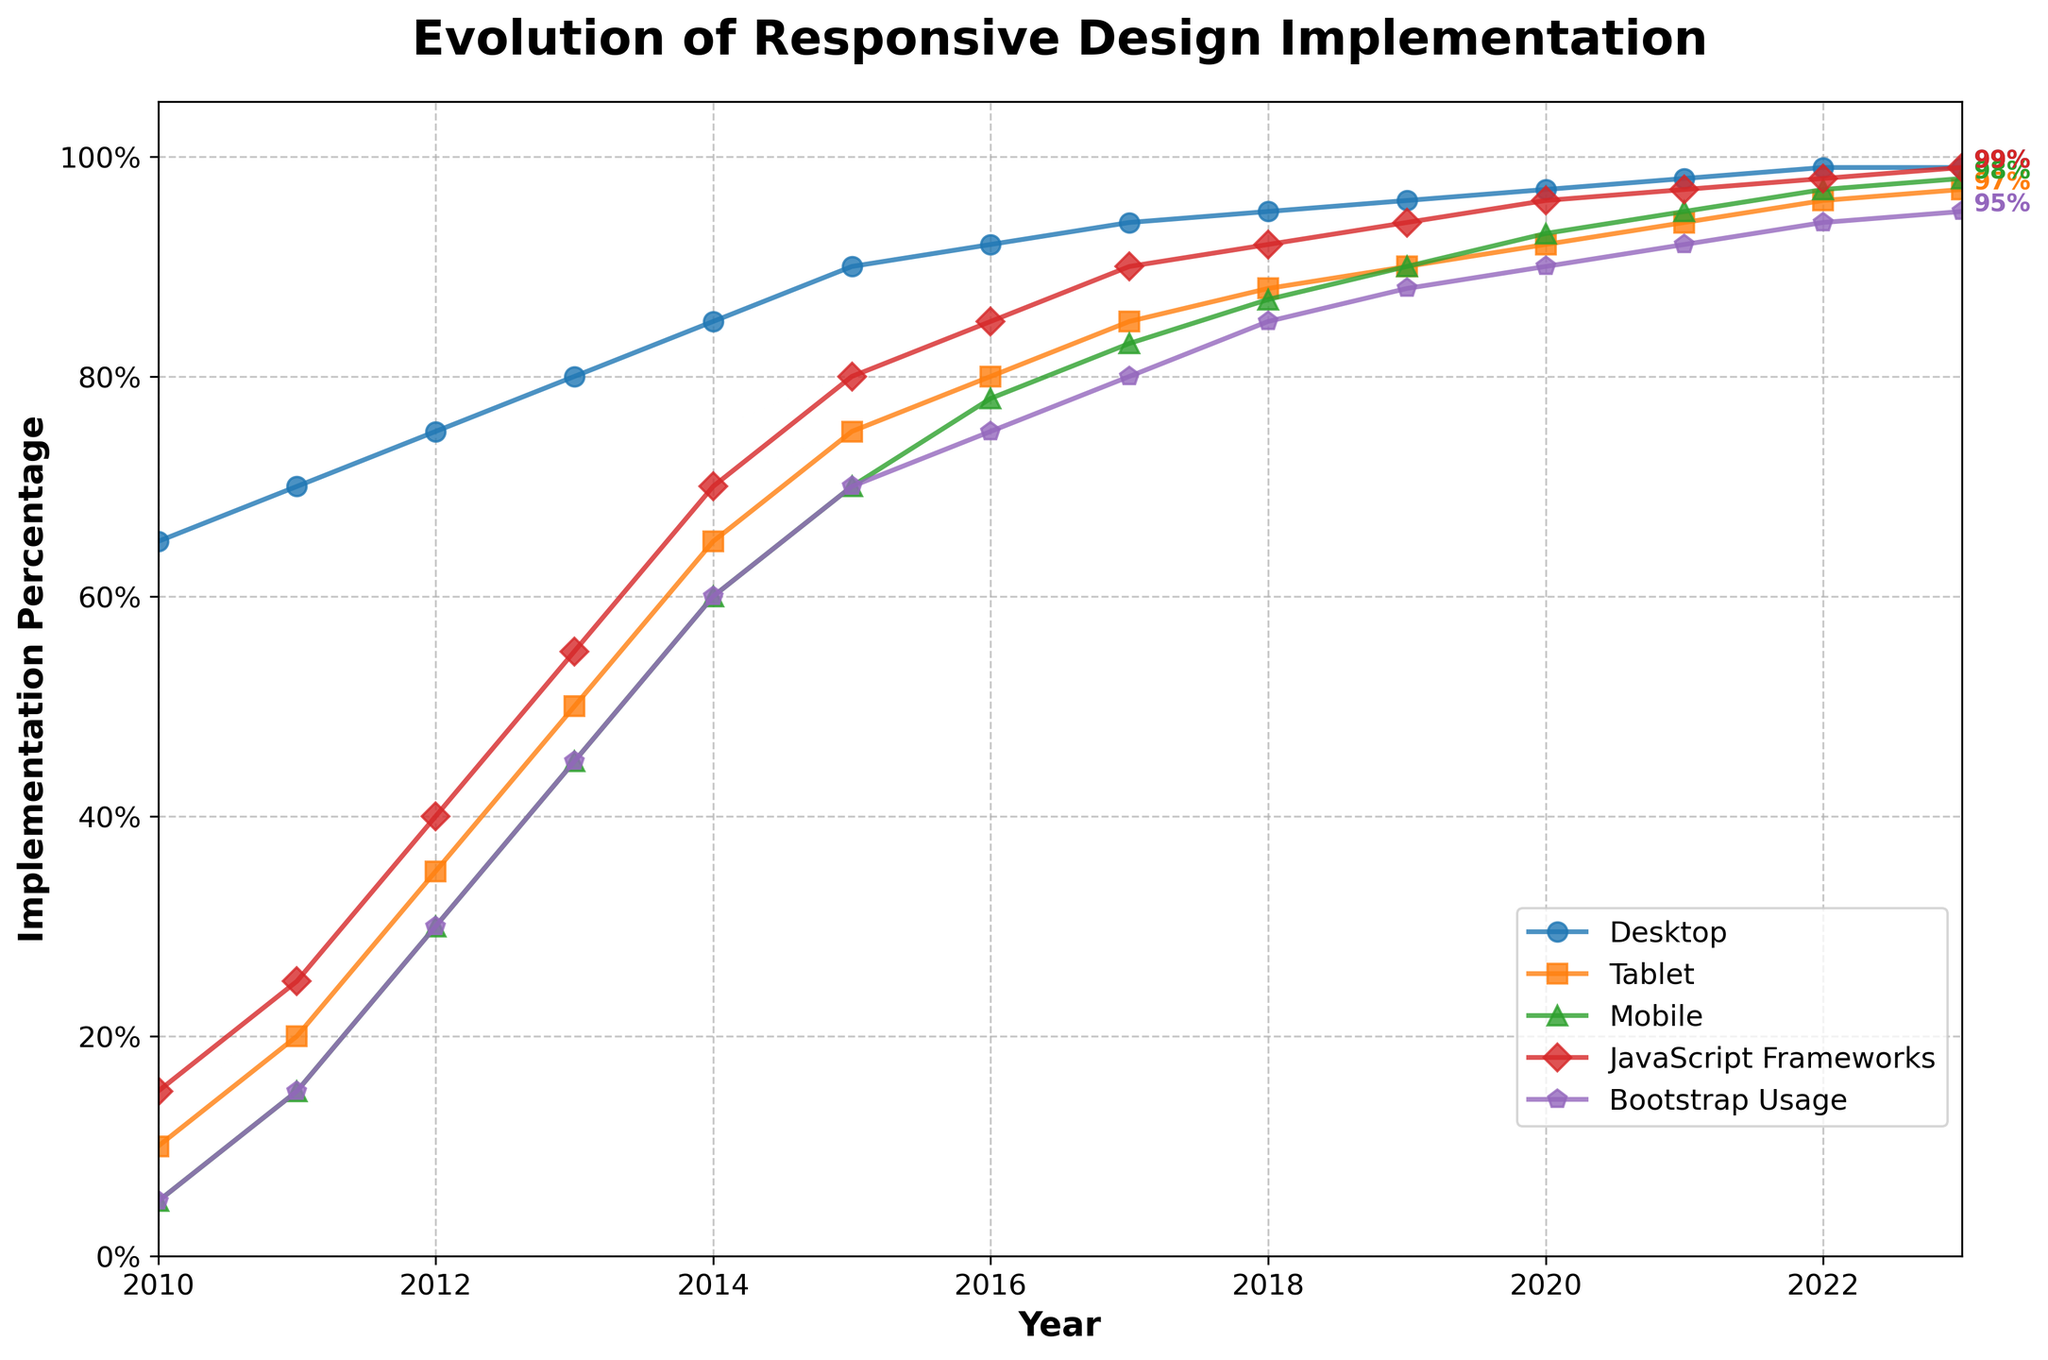How has the implementation percentage for mobile platforms evolved from 2010 to 2023? By observing the graph, the implementation percentage for mobile platforms started at 5% in 2010 and increased year by year, reaching 98% in 2023.
Answer: From 5% to 98% Which platform had the highest implementation percentage in 2023? By comparing the different lines in the figure for the year 2023, both Desktop and JavaScript Frameworks attained the highest percentage at 99%.
Answer: Desktop and JavaScript Frameworks In which year did the percentage of Bootstrap Usage exceed 50%? By identifying the point at which the Bootstrap Usage line crosses above 50%, it is evident that it happened in 2014.
Answer: 2014 What is the difference in the implementation percentage between Desktop and Tablet platforms in 2020? Observing the data points in the year 2020, Desktop has 97% and Tablet has 92%. The difference is calculated as 97% - 92% = 5%.
Answer: 5% Between which two consecutive years did Mobile platforms see the largest percentage increase? Reviewing the steepness of the Mobile platform lines between consecutive years, the largest increase is found between 2011 (15%) and 2012 (30%), resulting in a 15% increase.
Answer: 2011 and 2012 Compare the implementation percentage of JavaScript Frameworks from 2010 and 2023. JavaScript Frameworks had an implementation percentage of 15% in 2010 and 99% in 2023. Comparing these values, there was an 84% increase.
Answer: 84% What is the average implementation percentage of Bootstrap Usage from 2015 to 2019? Refer to the data points for each year within the range: 70% in 2015, 75% in 2016, 80% in 2017, 85% in 2018, 88% in 2019. The average is (70 + 75 + 80 + 85 + 88)/5 = 79.6%.
Answer: 79.6% Which platform showed a consistent increase every year from 2010 through 2023? By examining the plotted data, each line is evaluated. Desktop, Tablet, Mobile, JavaScript Frameworks, and Bootstrap Usage all show a consistent increase yearly.
Answer: All platforms In 2016, how did Tablet implementation compare to Mobile implementation? Looking at the points corresponding to 2016, Tablet had an implementation of 80%, while Mobile had 78%, indicating Tablet was 2% higher.
Answer: 2% higher 